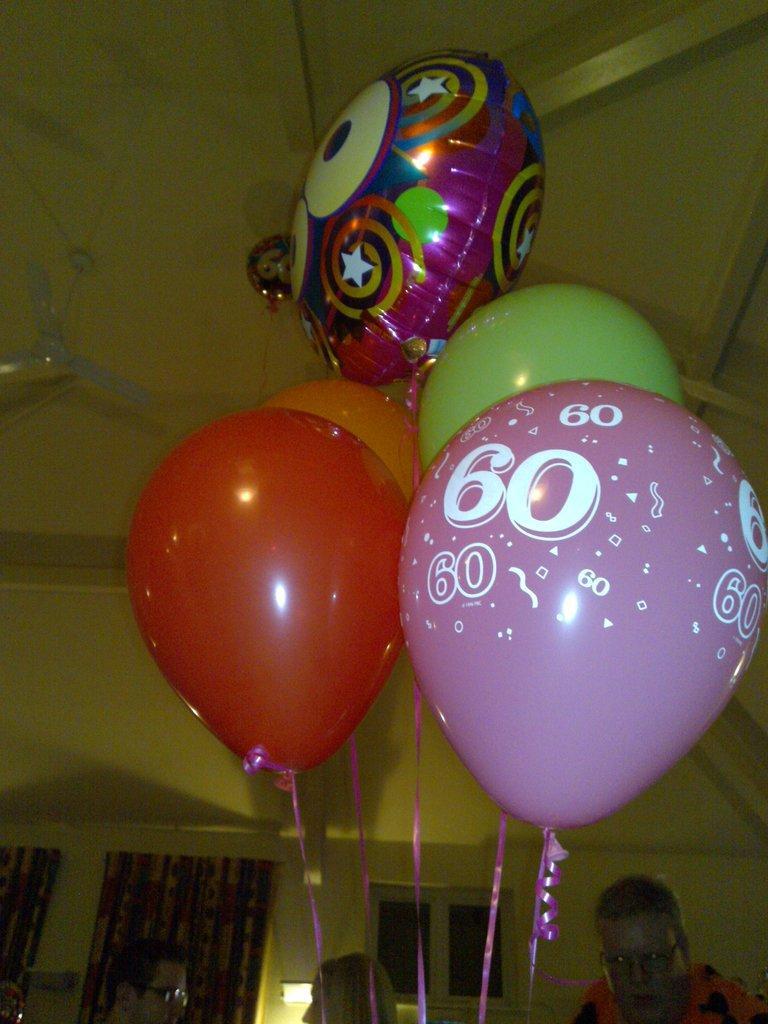How would you summarize this image in a sentence or two? In this image we can see a group of balloons tied with ribbons. We can also see some people, a wall, a curtain, window, light and a ceiling light to a roof. 